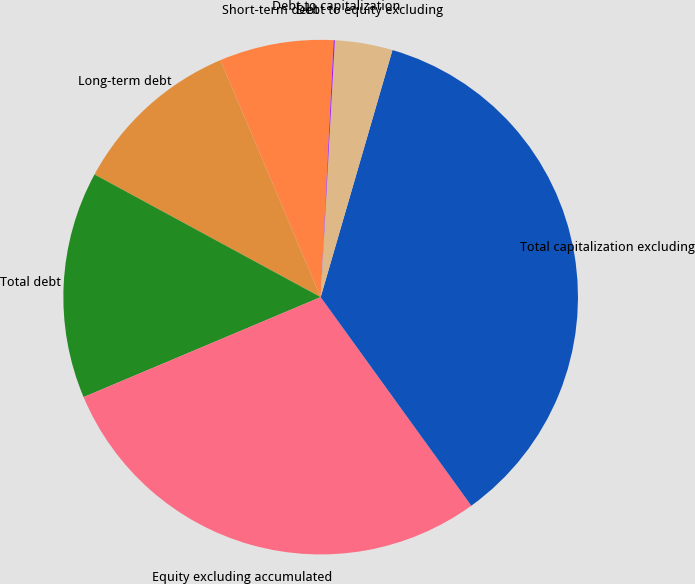Convert chart to OTSL. <chart><loc_0><loc_0><loc_500><loc_500><pie_chart><fcel>Short-term debt<fcel>Long-term debt<fcel>Total debt<fcel>Equity excluding accumulated<fcel>Total capitalization excluding<fcel>Debt to equity excluding<fcel>Debt to capitalization<nl><fcel>7.17%<fcel>10.72%<fcel>14.26%<fcel>28.6%<fcel>35.54%<fcel>3.62%<fcel>0.08%<nl></chart> 